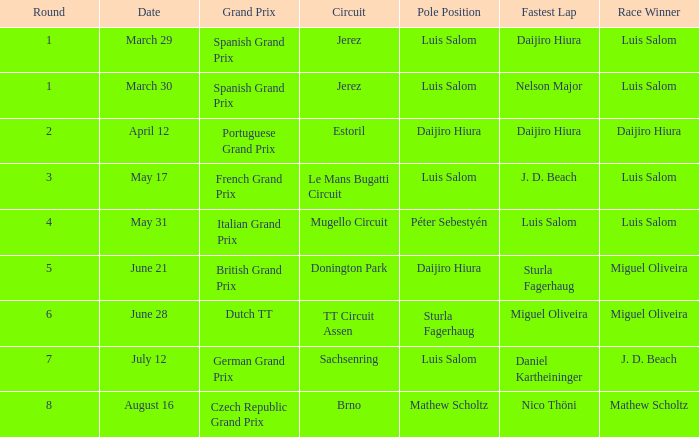What grand prixs did Daijiro Hiura win?  Portuguese Grand Prix. 